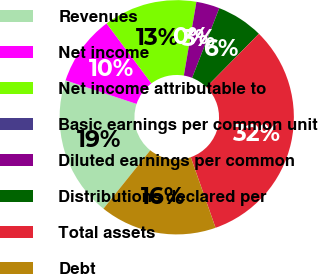Convert chart. <chart><loc_0><loc_0><loc_500><loc_500><pie_chart><fcel>Revenues<fcel>Net income<fcel>Net income attributable to<fcel>Basic earnings per common unit<fcel>Diluted earnings per common<fcel>Distributions declared per<fcel>Total assets<fcel>Debt<nl><fcel>19.35%<fcel>9.68%<fcel>12.9%<fcel>0.0%<fcel>3.23%<fcel>6.45%<fcel>32.25%<fcel>16.13%<nl></chart> 